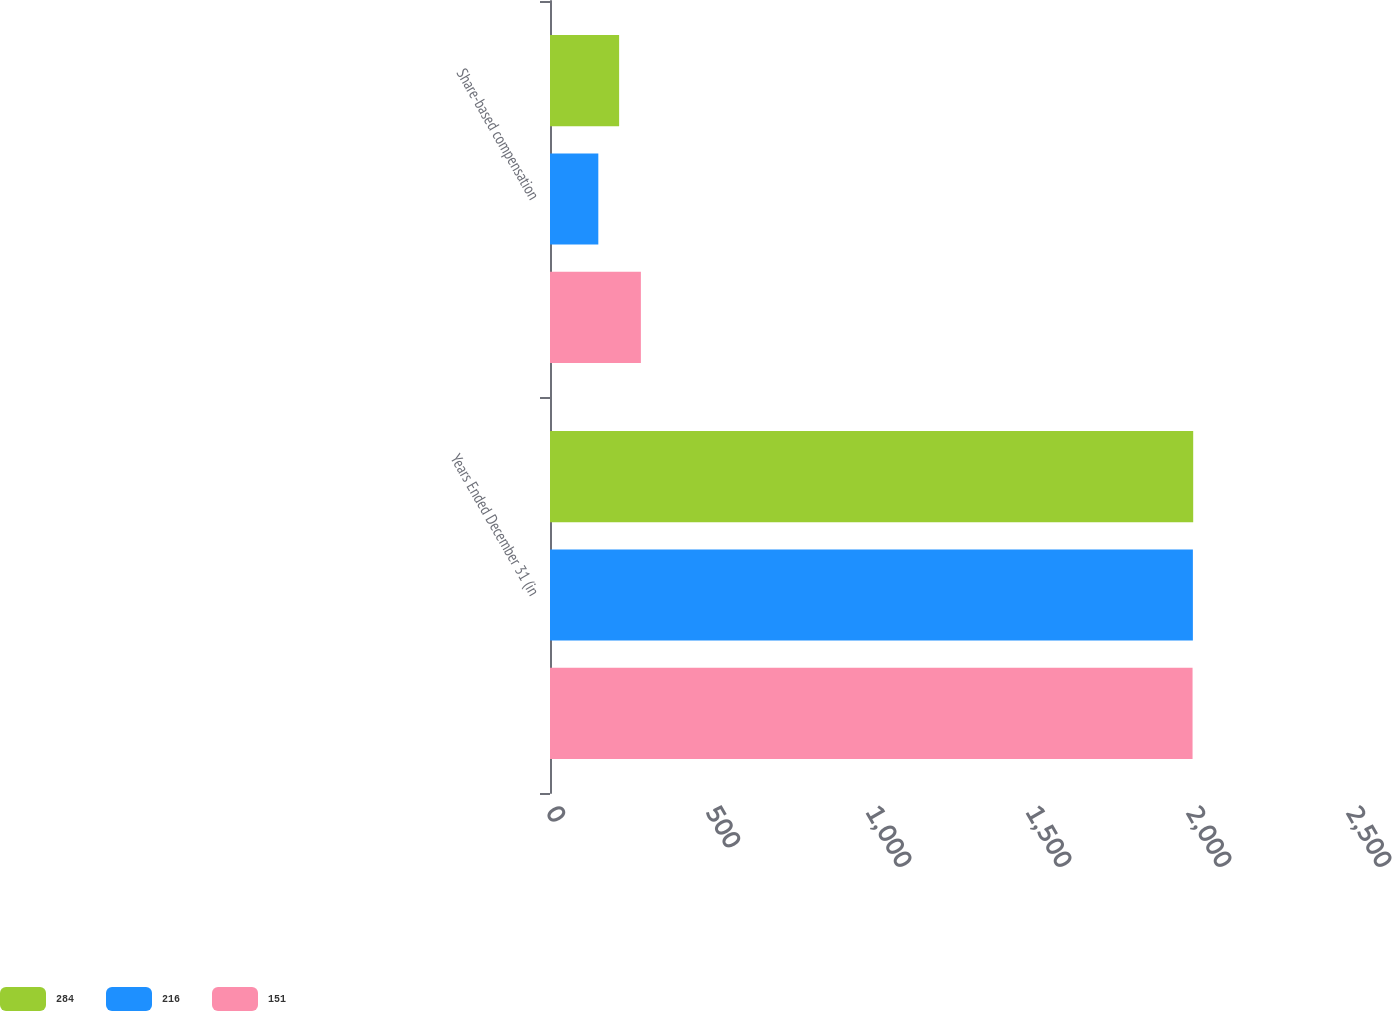<chart> <loc_0><loc_0><loc_500><loc_500><stacked_bar_chart><ecel><fcel>Years Ended December 31 (in<fcel>Share-based compensation<nl><fcel>284<fcel>2010<fcel>216<nl><fcel>216<fcel>2009<fcel>151<nl><fcel>151<fcel>2008<fcel>284<nl></chart> 